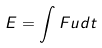<formula> <loc_0><loc_0><loc_500><loc_500>E = \int F u d t</formula> 